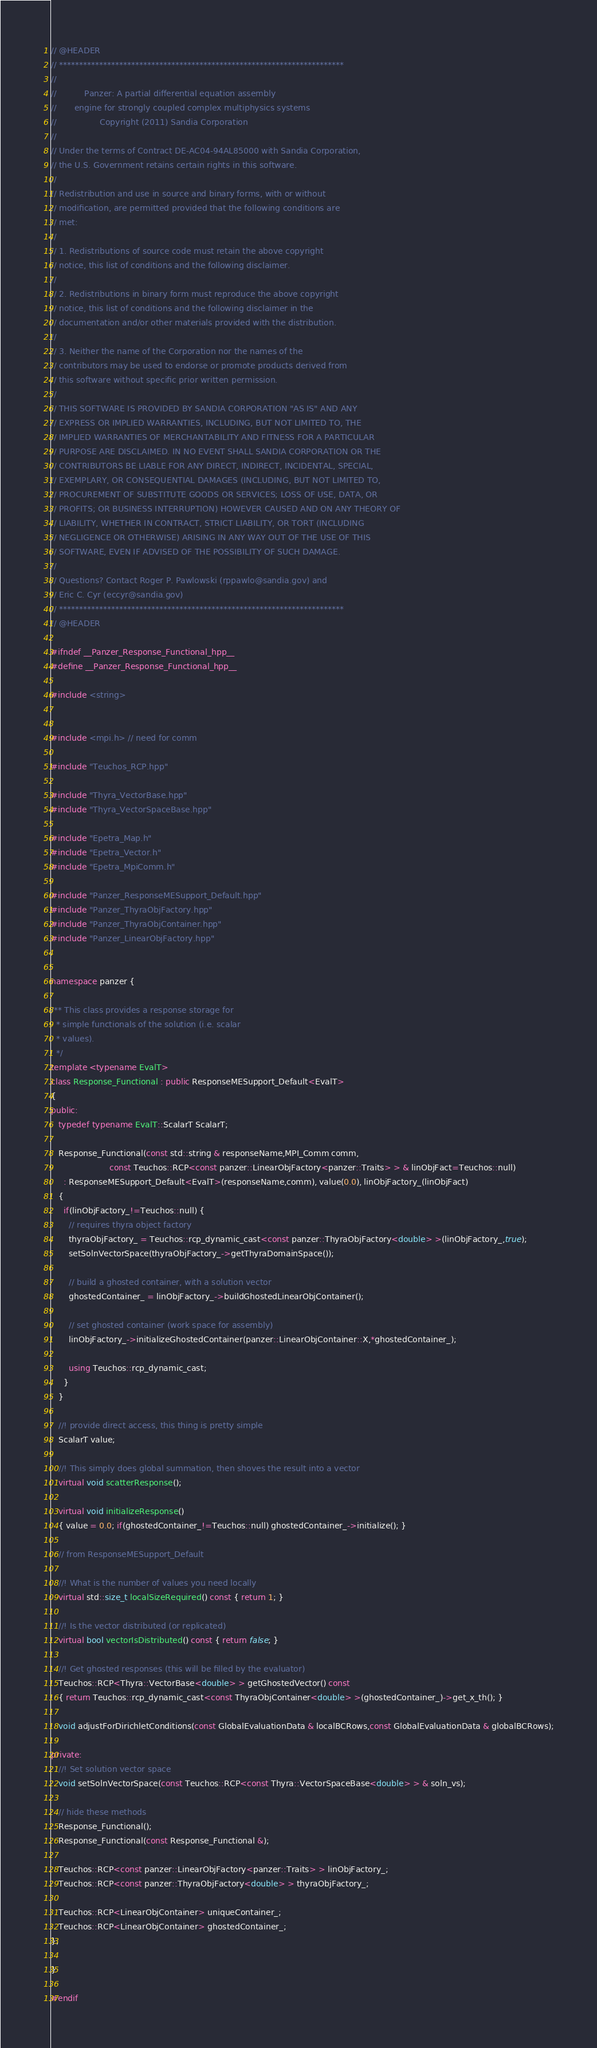<code> <loc_0><loc_0><loc_500><loc_500><_C++_>// @HEADER
// ***********************************************************************
//
//           Panzer: A partial differential equation assembly
//       engine for strongly coupled complex multiphysics systems
//                 Copyright (2011) Sandia Corporation
//
// Under the terms of Contract DE-AC04-94AL85000 with Sandia Corporation,
// the U.S. Government retains certain rights in this software.
//
// Redistribution and use in source and binary forms, with or without
// modification, are permitted provided that the following conditions are
// met:
//
// 1. Redistributions of source code must retain the above copyright
// notice, this list of conditions and the following disclaimer.
//
// 2. Redistributions in binary form must reproduce the above copyright
// notice, this list of conditions and the following disclaimer in the
// documentation and/or other materials provided with the distribution.
//
// 3. Neither the name of the Corporation nor the names of the
// contributors may be used to endorse or promote products derived from
// this software without specific prior written permission.
//
// THIS SOFTWARE IS PROVIDED BY SANDIA CORPORATION "AS IS" AND ANY
// EXPRESS OR IMPLIED WARRANTIES, INCLUDING, BUT NOT LIMITED TO, THE
// IMPLIED WARRANTIES OF MERCHANTABILITY AND FITNESS FOR A PARTICULAR
// PURPOSE ARE DISCLAIMED. IN NO EVENT SHALL SANDIA CORPORATION OR THE
// CONTRIBUTORS BE LIABLE FOR ANY DIRECT, INDIRECT, INCIDENTAL, SPECIAL,
// EXEMPLARY, OR CONSEQUENTIAL DAMAGES (INCLUDING, BUT NOT LIMITED TO,
// PROCUREMENT OF SUBSTITUTE GOODS OR SERVICES; LOSS OF USE, DATA, OR
// PROFITS; OR BUSINESS INTERRUPTION) HOWEVER CAUSED AND ON ANY THEORY OF
// LIABILITY, WHETHER IN CONTRACT, STRICT LIABILITY, OR TORT (INCLUDING
// NEGLIGENCE OR OTHERWISE) ARISING IN ANY WAY OUT OF THE USE OF THIS
// SOFTWARE, EVEN IF ADVISED OF THE POSSIBILITY OF SUCH DAMAGE.
//
// Questions? Contact Roger P. Pawlowski (rppawlo@sandia.gov) and
// Eric C. Cyr (eccyr@sandia.gov)
// ***********************************************************************
// @HEADER

#ifndef __Panzer_Response_Functional_hpp__
#define __Panzer_Response_Functional_hpp__

#include <string>


#include <mpi.h> // need for comm

#include "Teuchos_RCP.hpp"

#include "Thyra_VectorBase.hpp"
#include "Thyra_VectorSpaceBase.hpp"

#include "Epetra_Map.h"
#include "Epetra_Vector.h"
#include "Epetra_MpiComm.h"

#include "Panzer_ResponseMESupport_Default.hpp"
#include "Panzer_ThyraObjFactory.hpp"
#include "Panzer_ThyraObjContainer.hpp"
#include "Panzer_LinearObjFactory.hpp"


namespace panzer {

/** This class provides a response storage for
  * simple functionals of the solution (i.e. scalar
  * values).
  */
template <typename EvalT>
class Response_Functional : public ResponseMESupport_Default<EvalT>
{
public:
   typedef typename EvalT::ScalarT ScalarT;

   Response_Functional(const std::string & responseName,MPI_Comm comm,
                       const Teuchos::RCP<const panzer::LinearObjFactory<panzer::Traits> > & linObjFact=Teuchos::null)
     : ResponseMESupport_Default<EvalT>(responseName,comm), value(0.0), linObjFactory_(linObjFact)
   {
     if(linObjFactory_!=Teuchos::null) {
       // requires thyra object factory
       thyraObjFactory_ = Teuchos::rcp_dynamic_cast<const panzer::ThyraObjFactory<double> >(linObjFactory_,true);
       setSolnVectorSpace(thyraObjFactory_->getThyraDomainSpace());

       // build a ghosted container, with a solution vector
       ghostedContainer_ = linObjFactory_->buildGhostedLinearObjContainer();

       // set ghosted container (work space for assembly)
       linObjFactory_->initializeGhostedContainer(panzer::LinearObjContainer::X,*ghostedContainer_);

       using Teuchos::rcp_dynamic_cast;
     }
   }

   //! provide direct access, this thing is pretty simple
   ScalarT value;

   //! This simply does global summation, then shoves the result into a vector
   virtual void scatterResponse();

   virtual void initializeResponse()  
   { value = 0.0; if(ghostedContainer_!=Teuchos::null) ghostedContainer_->initialize(); }

   // from ResponseMESupport_Default

   //! What is the number of values you need locally
   virtual std::size_t localSizeRequired() const { return 1; }

   //! Is the vector distributed (or replicated)
   virtual bool vectorIsDistributed() const { return false; }

   //! Get ghosted responses (this will be filled by the evaluator)
   Teuchos::RCP<Thyra::VectorBase<double> > getGhostedVector() const
   { return Teuchos::rcp_dynamic_cast<const ThyraObjContainer<double> >(ghostedContainer_)->get_x_th(); }

   void adjustForDirichletConditions(const GlobalEvaluationData & localBCRows,const GlobalEvaluationData & globalBCRows);
    
private:
   //! Set solution vector space
   void setSolnVectorSpace(const Teuchos::RCP<const Thyra::VectorSpaceBase<double> > & soln_vs);

   // hide these methods
   Response_Functional();
   Response_Functional(const Response_Functional &);

   Teuchos::RCP<const panzer::LinearObjFactory<panzer::Traits> > linObjFactory_;
   Teuchos::RCP<const panzer::ThyraObjFactory<double> > thyraObjFactory_;

   Teuchos::RCP<LinearObjContainer> uniqueContainer_;
   Teuchos::RCP<LinearObjContainer> ghostedContainer_;
};

}

#endif
</code> 